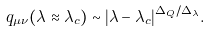Convert formula to latex. <formula><loc_0><loc_0><loc_500><loc_500>q _ { \mu \nu } ( \lambda \approx \lambda _ { c } ) \sim | \lambda - \lambda _ { c } | ^ { \Delta _ { Q } / \Delta _ { \lambda } } .</formula> 